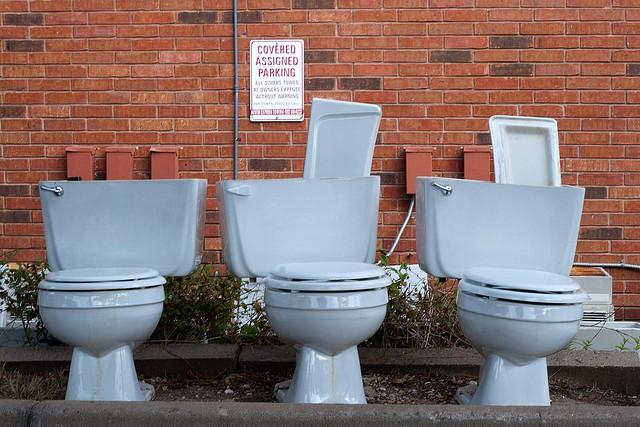How many toilet bowls are sat in this area next to the side of the street? three 